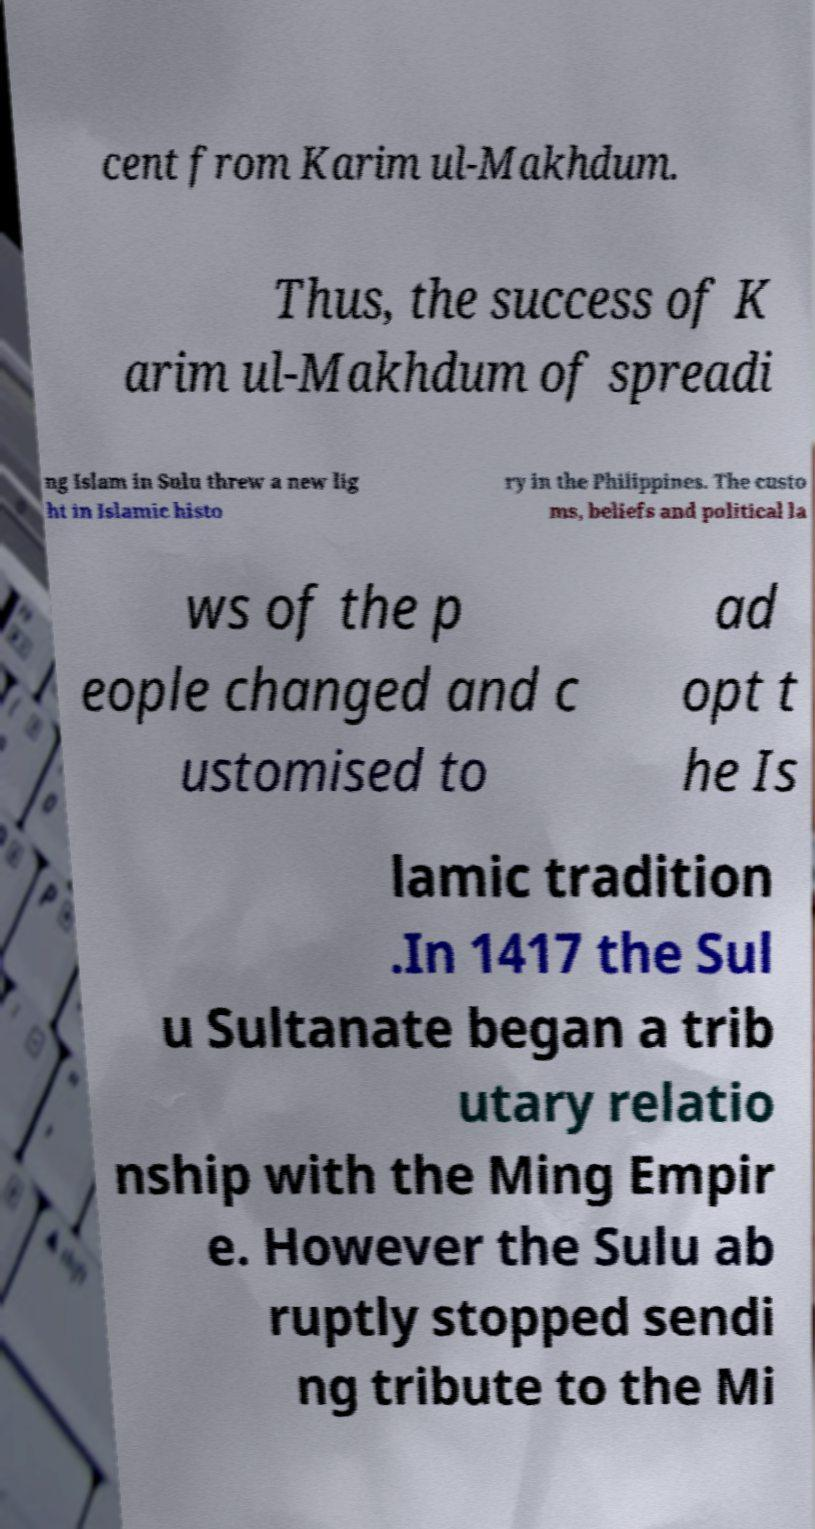Could you assist in decoding the text presented in this image and type it out clearly? cent from Karim ul-Makhdum. Thus, the success of K arim ul-Makhdum of spreadi ng Islam in Sulu threw a new lig ht in Islamic histo ry in the Philippines. The custo ms, beliefs and political la ws of the p eople changed and c ustomised to ad opt t he Is lamic tradition .In 1417 the Sul u Sultanate began a trib utary relatio nship with the Ming Empir e. However the Sulu ab ruptly stopped sendi ng tribute to the Mi 